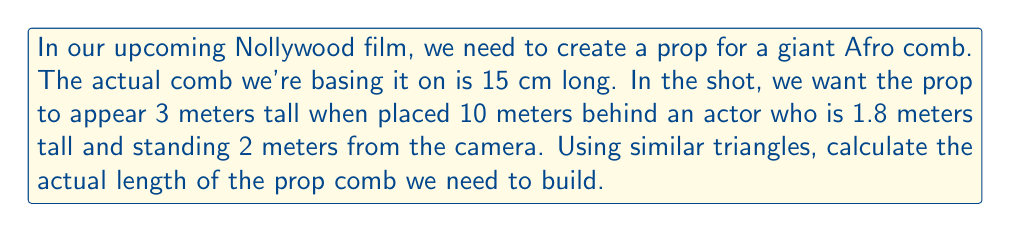Give your solution to this math problem. Let's approach this step-by-step using similar triangles:

1) We can form two similar triangles:
   - Triangle 1: Camera to actor to actor's height
   - Triangle 2: Camera to prop to prop's height

2) Let's define variables:
   $x$ = actual length of the prop comb
   $d_1$ = distance from camera to actor = 2 m
   $d_2$ = distance from camera to prop = 2 m + 10 m = 12 m
   $h_1$ = actor's height = 1.8 m
   $h_2$ = apparent height of prop = 3 m

3) The ratio of the sides in similar triangles is constant. So:

   $$\frac{h_1}{d_1} = \frac{h_2}{d_2}$$

4) We can also write a similar ratio for the actual and apparent sizes of the prop:

   $$\frac{15 \text{ cm}}{x} = \frac{3 \text{ m}}{d_2}$$

5) From step 3:

   $$\frac{1.8}{2} = \frac{3}{12}$$

   This confirms our triangles are indeed similar.

6) From step 4:

   $$\frac{0.15}{x} = \frac{3}{12}$$

7) Cross multiply:

   $$12 \cdot 0.15 = 3x$$

8) Solve for $x$:

   $$x = \frac{12 \cdot 0.15}{3} = 0.6 \text{ m} = 60 \text{ cm}$$

Therefore, the actual prop comb needs to be 60 cm long.
Answer: 60 cm 